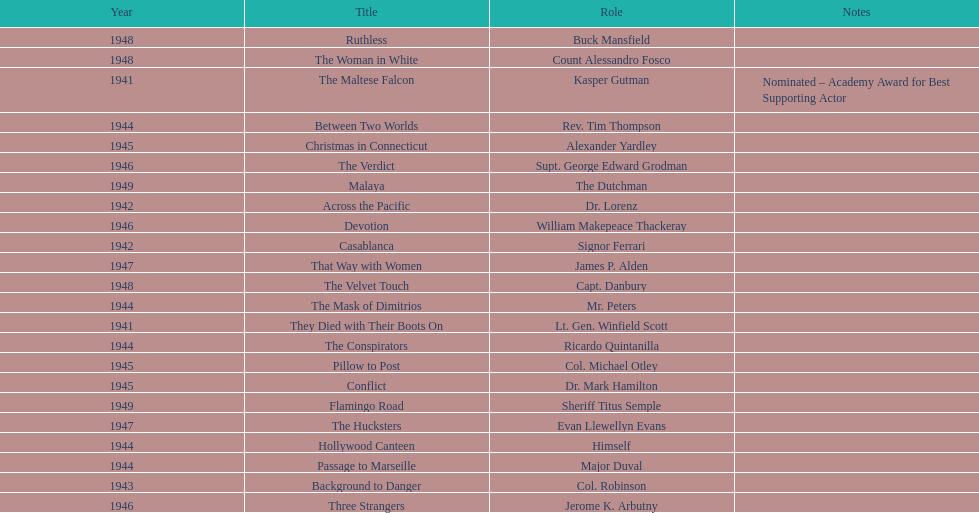How long did sydney greenstreet's acting career last? 9 years. 